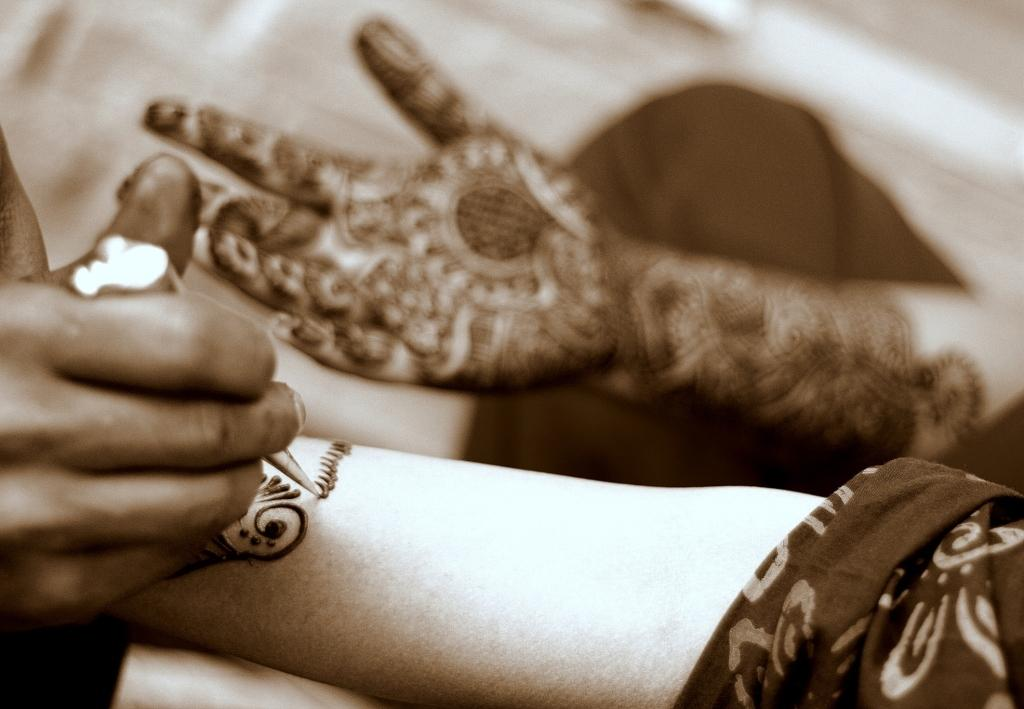What is the person in the image doing? The person in the image is applying mehndi. What tool is being used to apply the mehndi? The mehndi is being applied with the help of a cone. To which part of the body is the mehndi being applied? The mehndi is being applied to the hands of a person. Can you describe the hand with a design visible in the image? The hand with a design visible in the image is blurry, so it is difficult to describe the design in detail. What type of breakfast is being served on the van in the image? There is no van or breakfast present in the image; it features a person applying mehndi to someone's hands. 